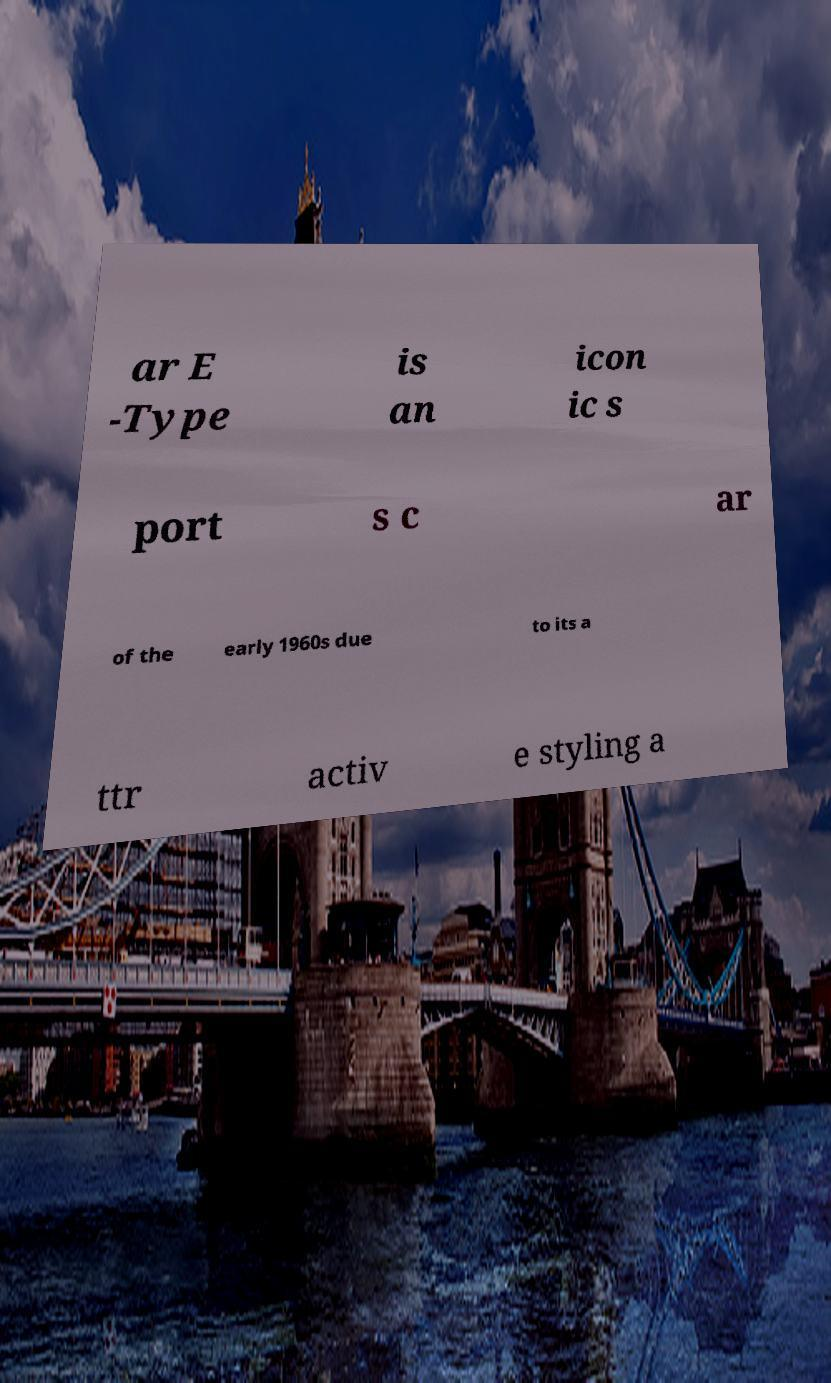Could you assist in decoding the text presented in this image and type it out clearly? ar E -Type is an icon ic s port s c ar of the early 1960s due to its a ttr activ e styling a 